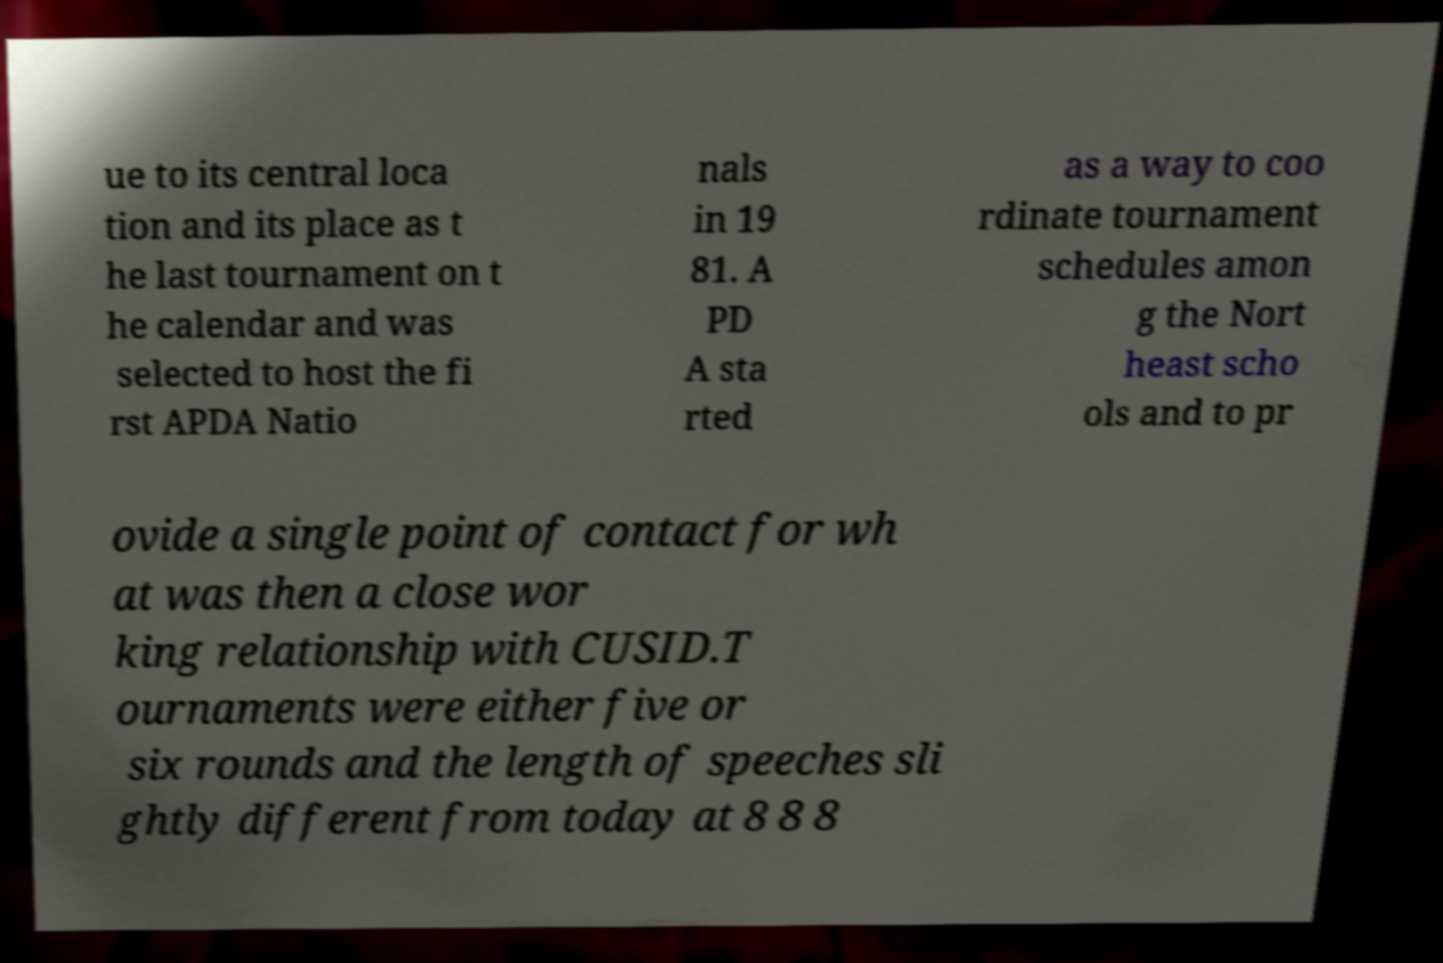Please read and relay the text visible in this image. What does it say? ue to its central loca tion and its place as t he last tournament on t he calendar and was selected to host the fi rst APDA Natio nals in 19 81. A PD A sta rted as a way to coo rdinate tournament schedules amon g the Nort heast scho ols and to pr ovide a single point of contact for wh at was then a close wor king relationship with CUSID.T ournaments were either five or six rounds and the length of speeches sli ghtly different from today at 8 8 8 